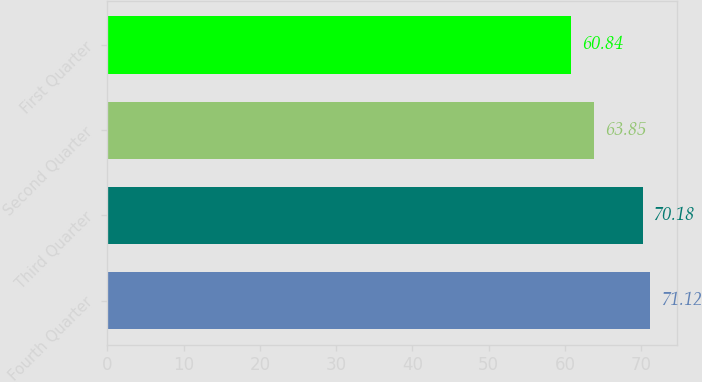Convert chart. <chart><loc_0><loc_0><loc_500><loc_500><bar_chart><fcel>Fourth Quarter<fcel>Third Quarter<fcel>Second Quarter<fcel>First Quarter<nl><fcel>71.12<fcel>70.18<fcel>63.85<fcel>60.84<nl></chart> 